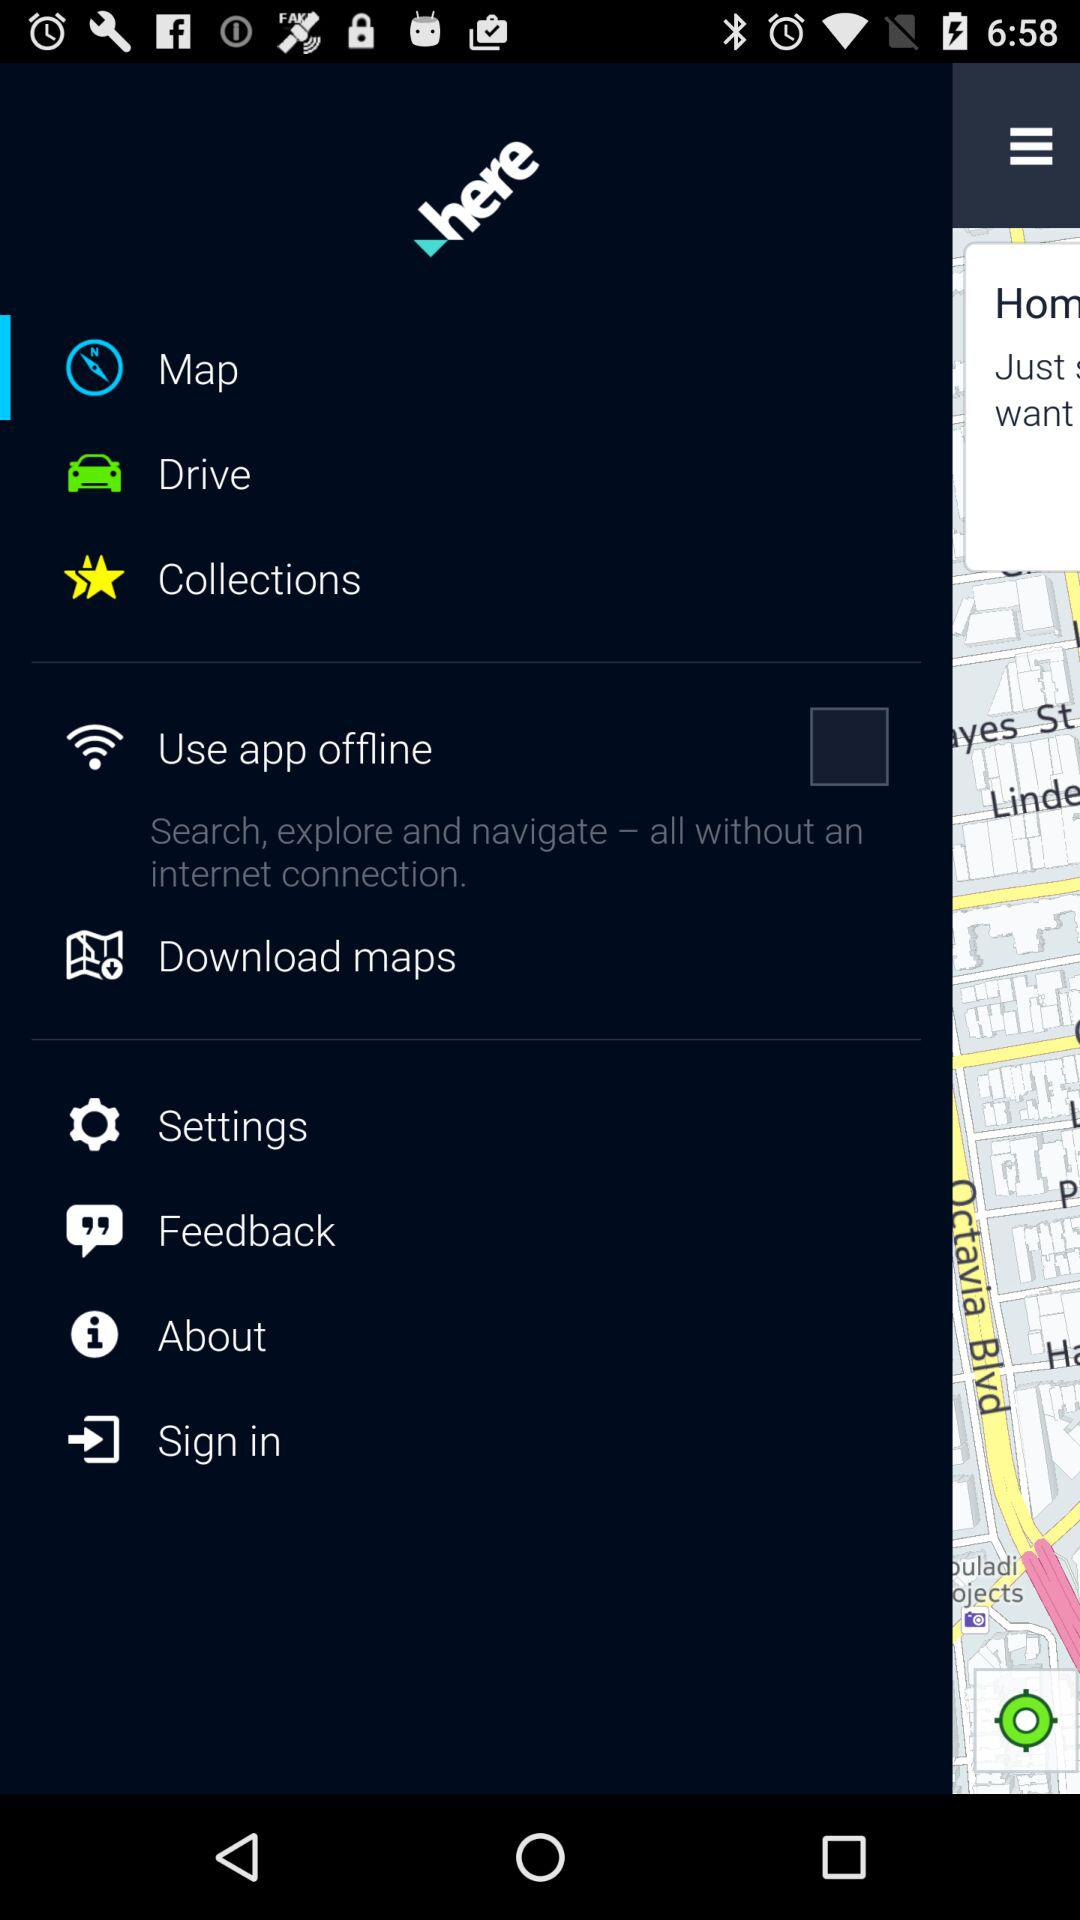How many items have a checkbox next to them?
Answer the question using a single word or phrase. 1 